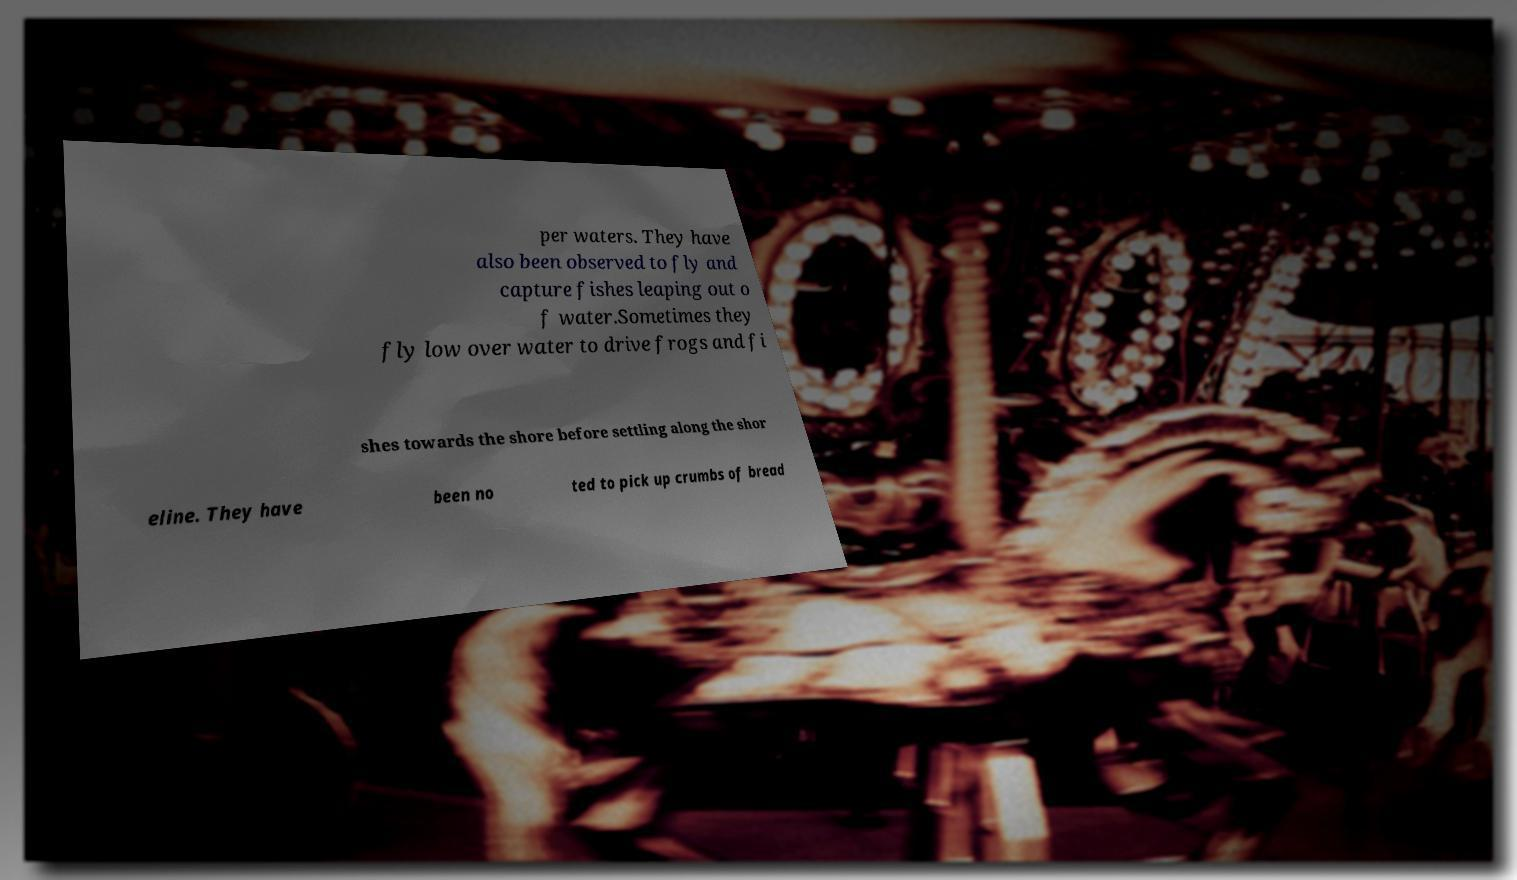Could you assist in decoding the text presented in this image and type it out clearly? per waters. They have also been observed to fly and capture fishes leaping out o f water.Sometimes they fly low over water to drive frogs and fi shes towards the shore before settling along the shor eline. They have been no ted to pick up crumbs of bread 